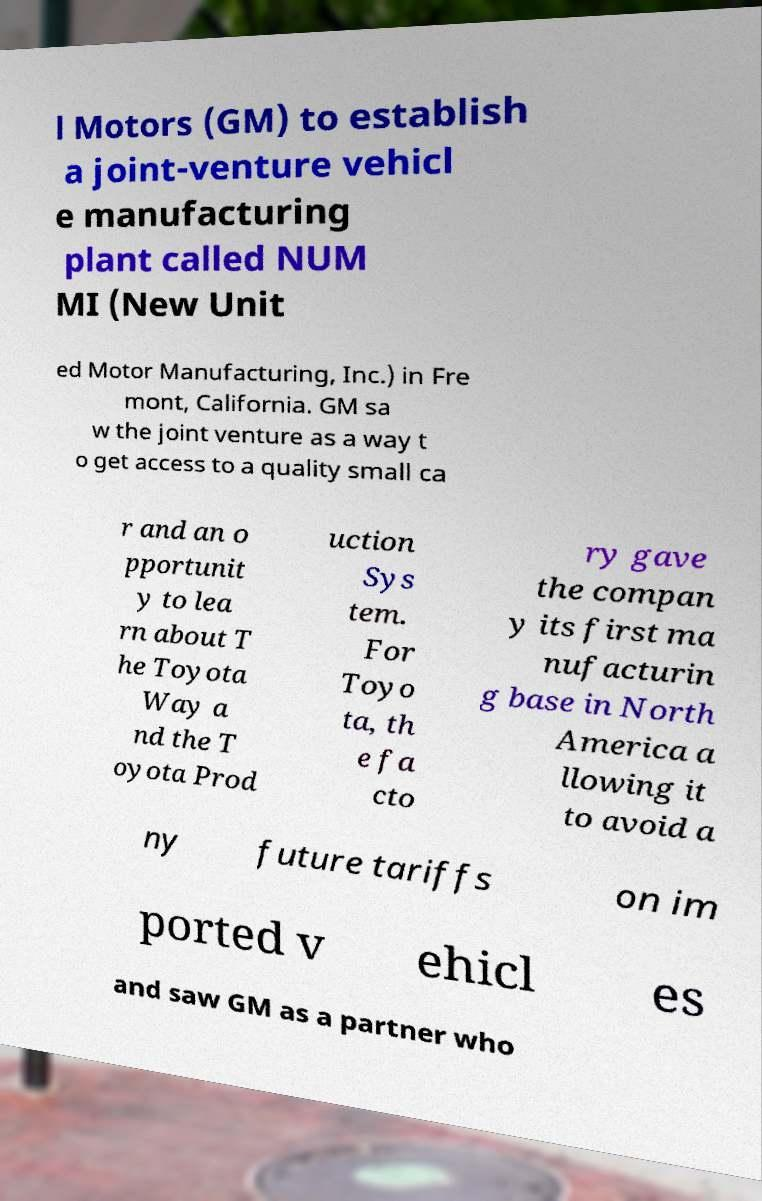Please identify and transcribe the text found in this image. l Motors (GM) to establish a joint-venture vehicl e manufacturing plant called NUM MI (New Unit ed Motor Manufacturing, Inc.) in Fre mont, California. GM sa w the joint venture as a way t o get access to a quality small ca r and an o pportunit y to lea rn about T he Toyota Way a nd the T oyota Prod uction Sys tem. For Toyo ta, th e fa cto ry gave the compan y its first ma nufacturin g base in North America a llowing it to avoid a ny future tariffs on im ported v ehicl es and saw GM as a partner who 